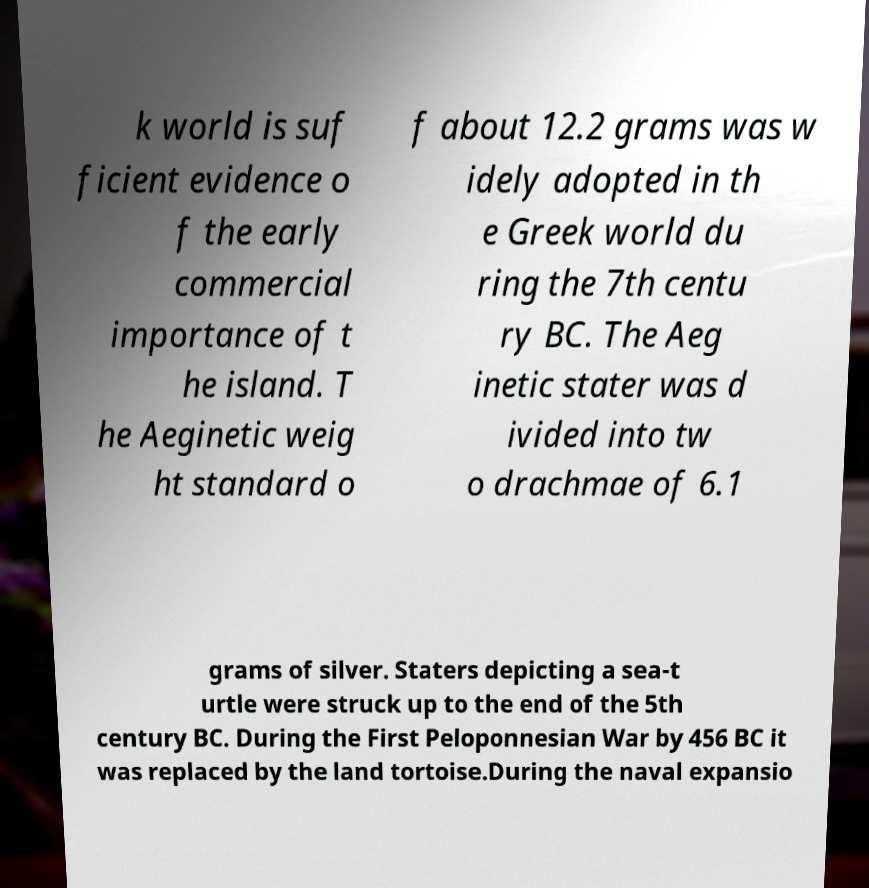For documentation purposes, I need the text within this image transcribed. Could you provide that? k world is suf ficient evidence o f the early commercial importance of t he island. T he Aeginetic weig ht standard o f about 12.2 grams was w idely adopted in th e Greek world du ring the 7th centu ry BC. The Aeg inetic stater was d ivided into tw o drachmae of 6.1 grams of silver. Staters depicting a sea-t urtle were struck up to the end of the 5th century BC. During the First Peloponnesian War by 456 BC it was replaced by the land tortoise.During the naval expansio 